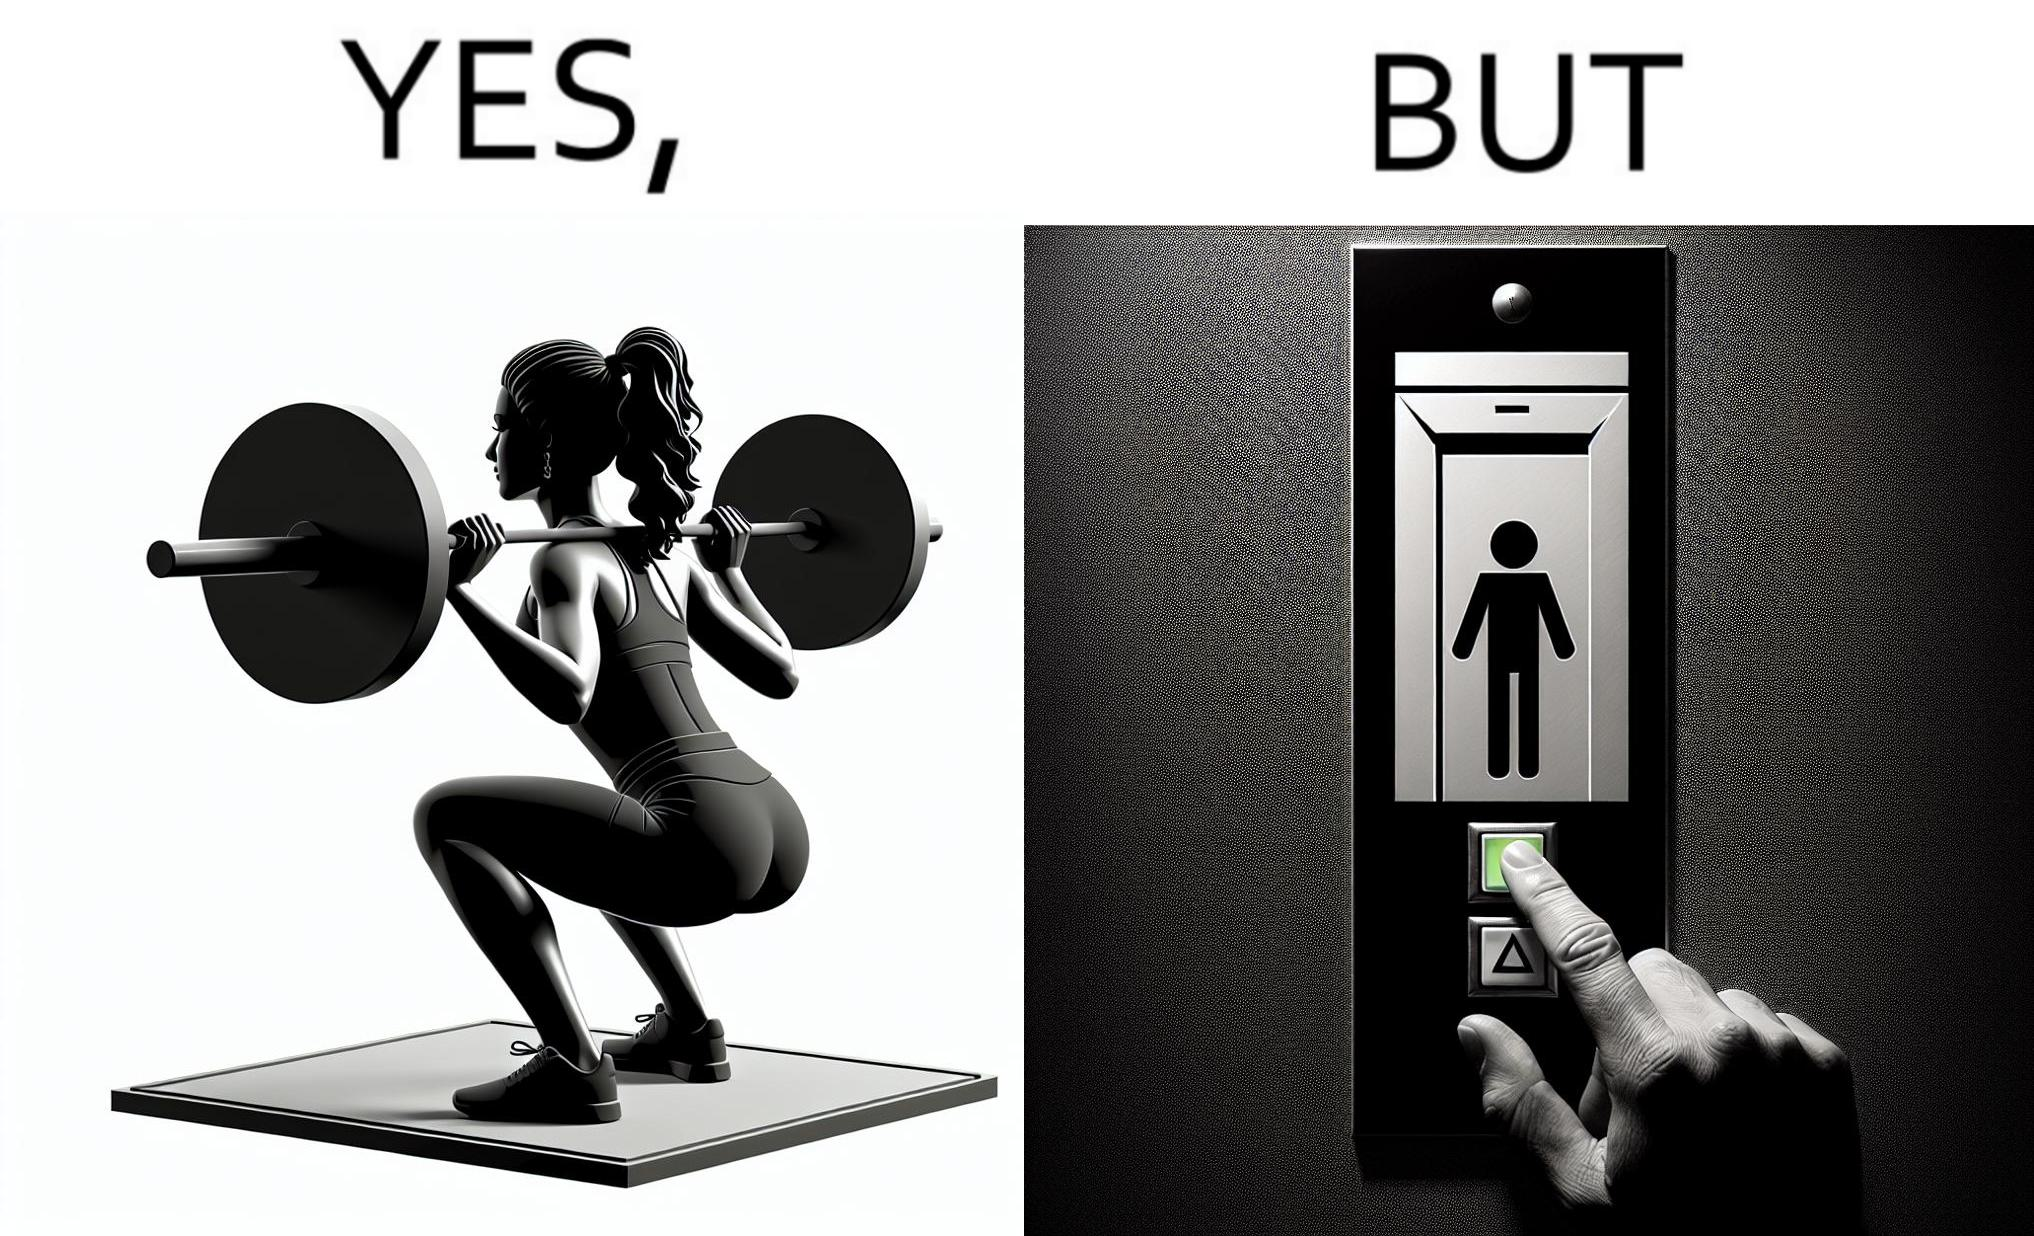Describe the satirical element in this image. The image is satirical because it shows that while people do various kinds of exercises and go to gym to stay fit, they avoid doing simplest of physical tasks like using stairs instead of elevators to get to even the first or the second floor of a building. 